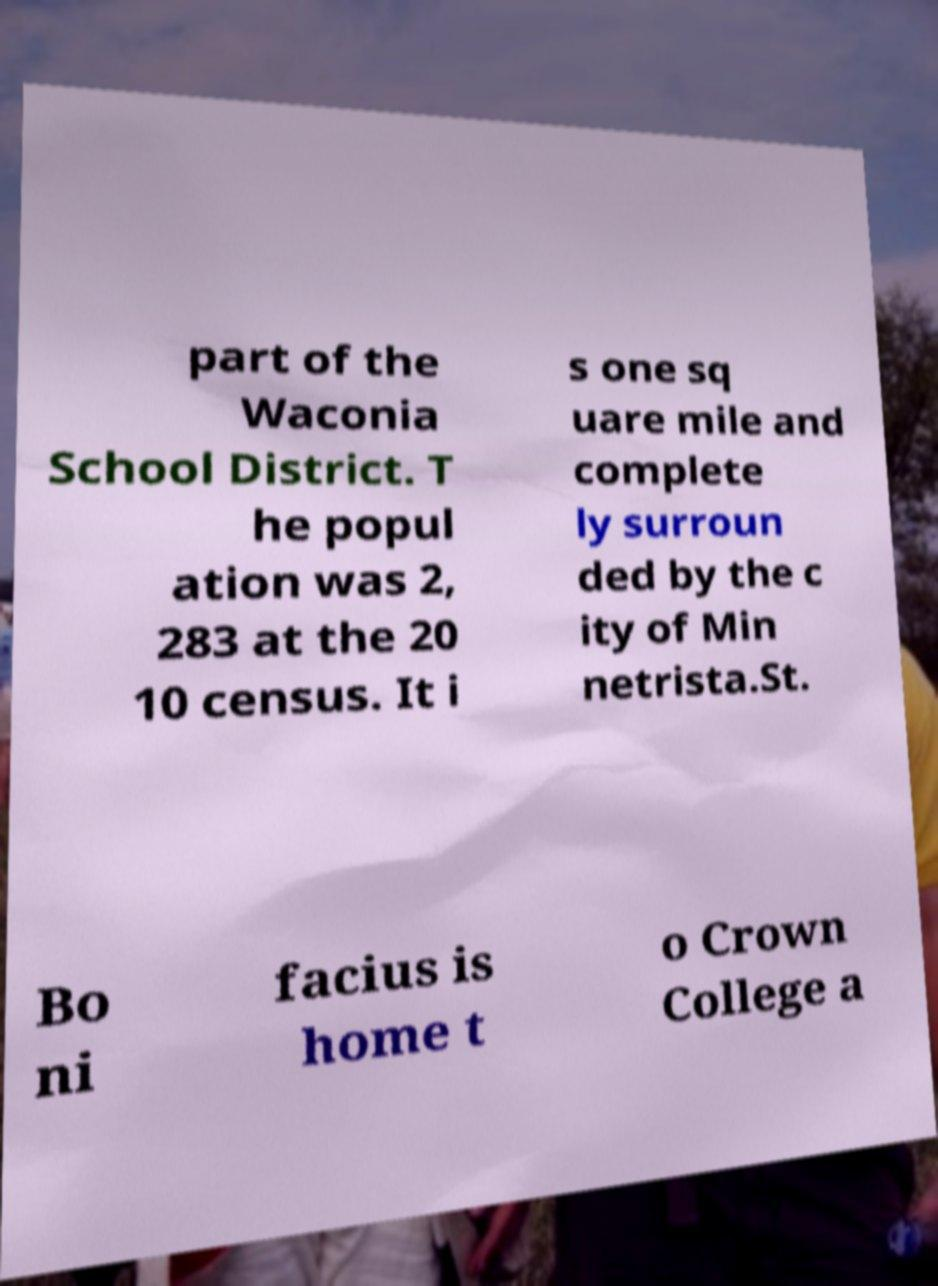Can you accurately transcribe the text from the provided image for me? part of the Waconia School District. T he popul ation was 2, 283 at the 20 10 census. It i s one sq uare mile and complete ly surroun ded by the c ity of Min netrista.St. Bo ni facius is home t o Crown College a 